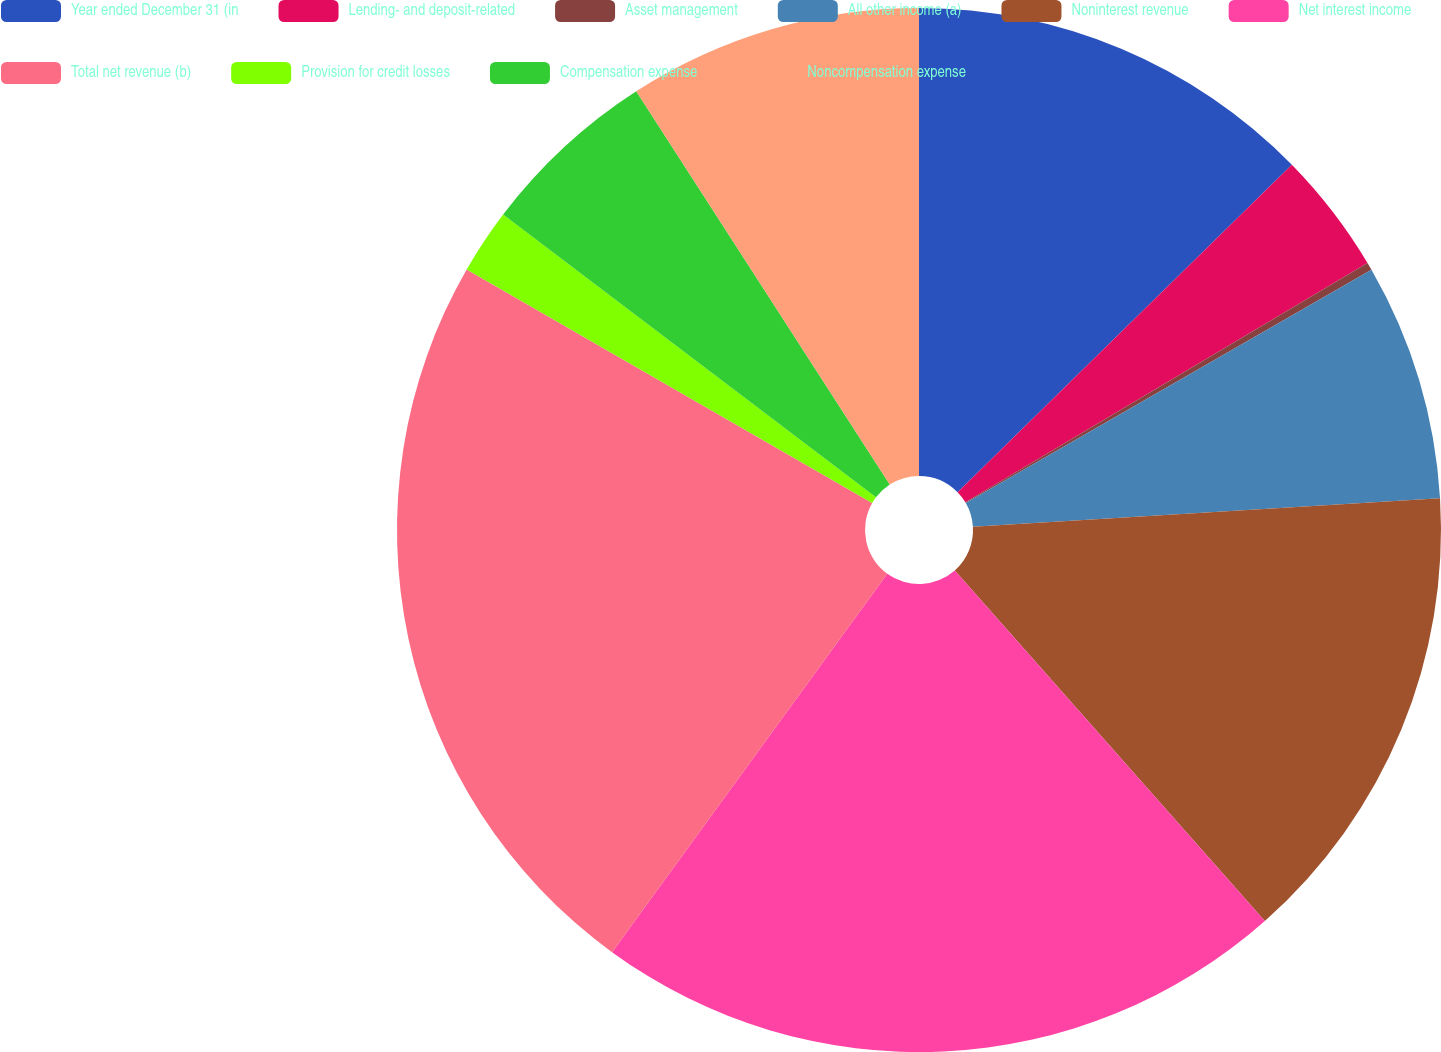Convert chart to OTSL. <chart><loc_0><loc_0><loc_500><loc_500><pie_chart><fcel>Year ended December 31 (in<fcel>Lending- and deposit-related<fcel>Asset management<fcel>All other income (a)<fcel>Noninterest revenue<fcel>Net interest income<fcel>Total net revenue (b)<fcel>Provision for credit losses<fcel>Compensation expense<fcel>Noncompensation expense<nl><fcel>12.66%<fcel>3.79%<fcel>0.24%<fcel>7.34%<fcel>14.44%<fcel>21.53%<fcel>23.31%<fcel>2.01%<fcel>5.56%<fcel>9.11%<nl></chart> 